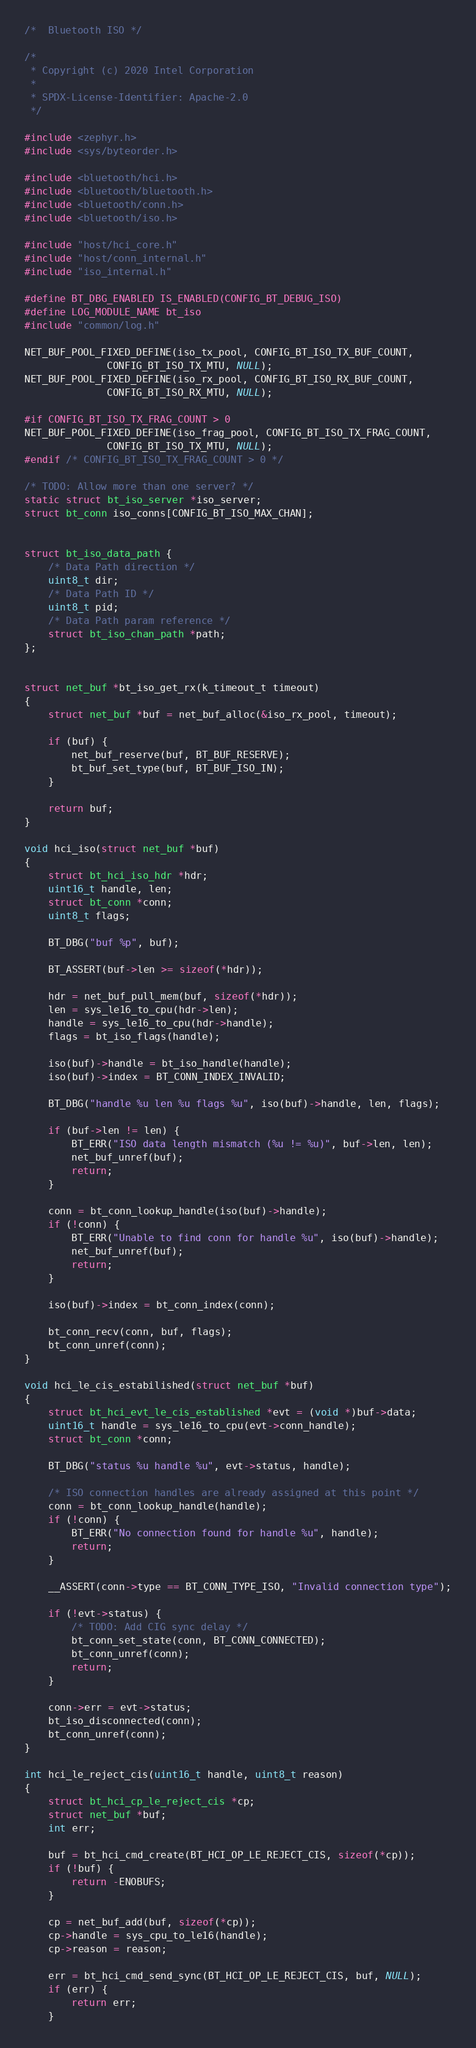<code> <loc_0><loc_0><loc_500><loc_500><_C_>/*  Bluetooth ISO */

/*
 * Copyright (c) 2020 Intel Corporation
 *
 * SPDX-License-Identifier: Apache-2.0
 */

#include <zephyr.h>
#include <sys/byteorder.h>

#include <bluetooth/hci.h>
#include <bluetooth/bluetooth.h>
#include <bluetooth/conn.h>
#include <bluetooth/iso.h>

#include "host/hci_core.h"
#include "host/conn_internal.h"
#include "iso_internal.h"

#define BT_DBG_ENABLED IS_ENABLED(CONFIG_BT_DEBUG_ISO)
#define LOG_MODULE_NAME bt_iso
#include "common/log.h"

NET_BUF_POOL_FIXED_DEFINE(iso_tx_pool, CONFIG_BT_ISO_TX_BUF_COUNT,
			  CONFIG_BT_ISO_TX_MTU, NULL);
NET_BUF_POOL_FIXED_DEFINE(iso_rx_pool, CONFIG_BT_ISO_RX_BUF_COUNT,
			  CONFIG_BT_ISO_RX_MTU, NULL);

#if CONFIG_BT_ISO_TX_FRAG_COUNT > 0
NET_BUF_POOL_FIXED_DEFINE(iso_frag_pool, CONFIG_BT_ISO_TX_FRAG_COUNT,
			  CONFIG_BT_ISO_TX_MTU, NULL);
#endif /* CONFIG_BT_ISO_TX_FRAG_COUNT > 0 */

/* TODO: Allow more than one server? */
static struct bt_iso_server *iso_server;
struct bt_conn iso_conns[CONFIG_BT_ISO_MAX_CHAN];


struct bt_iso_data_path {
	/* Data Path direction */
	uint8_t dir;
	/* Data Path ID */
	uint8_t pid;
	/* Data Path param reference */
	struct bt_iso_chan_path *path;
};


struct net_buf *bt_iso_get_rx(k_timeout_t timeout)
{
	struct net_buf *buf = net_buf_alloc(&iso_rx_pool, timeout);

	if (buf) {
		net_buf_reserve(buf, BT_BUF_RESERVE);
		bt_buf_set_type(buf, BT_BUF_ISO_IN);
	}

	return buf;
}

void hci_iso(struct net_buf *buf)
{
	struct bt_hci_iso_hdr *hdr;
	uint16_t handle, len;
	struct bt_conn *conn;
	uint8_t flags;

	BT_DBG("buf %p", buf);

	BT_ASSERT(buf->len >= sizeof(*hdr));

	hdr = net_buf_pull_mem(buf, sizeof(*hdr));
	len = sys_le16_to_cpu(hdr->len);
	handle = sys_le16_to_cpu(hdr->handle);
	flags = bt_iso_flags(handle);

	iso(buf)->handle = bt_iso_handle(handle);
	iso(buf)->index = BT_CONN_INDEX_INVALID;

	BT_DBG("handle %u len %u flags %u", iso(buf)->handle, len, flags);

	if (buf->len != len) {
		BT_ERR("ISO data length mismatch (%u != %u)", buf->len, len);
		net_buf_unref(buf);
		return;
	}

	conn = bt_conn_lookup_handle(iso(buf)->handle);
	if (!conn) {
		BT_ERR("Unable to find conn for handle %u", iso(buf)->handle);
		net_buf_unref(buf);
		return;
	}

	iso(buf)->index = bt_conn_index(conn);

	bt_conn_recv(conn, buf, flags);
	bt_conn_unref(conn);
}

void hci_le_cis_estabilished(struct net_buf *buf)
{
	struct bt_hci_evt_le_cis_established *evt = (void *)buf->data;
	uint16_t handle = sys_le16_to_cpu(evt->conn_handle);
	struct bt_conn *conn;

	BT_DBG("status %u handle %u", evt->status, handle);

	/* ISO connection handles are already assigned at this point */
	conn = bt_conn_lookup_handle(handle);
	if (!conn) {
		BT_ERR("No connection found for handle %u", handle);
		return;
	}

	__ASSERT(conn->type == BT_CONN_TYPE_ISO, "Invalid connection type");

	if (!evt->status) {
		/* TODO: Add CIG sync delay */
		bt_conn_set_state(conn, BT_CONN_CONNECTED);
		bt_conn_unref(conn);
		return;
	}

	conn->err = evt->status;
	bt_iso_disconnected(conn);
	bt_conn_unref(conn);
}

int hci_le_reject_cis(uint16_t handle, uint8_t reason)
{
	struct bt_hci_cp_le_reject_cis *cp;
	struct net_buf *buf;
	int err;

	buf = bt_hci_cmd_create(BT_HCI_OP_LE_REJECT_CIS, sizeof(*cp));
	if (!buf) {
		return -ENOBUFS;
	}

	cp = net_buf_add(buf, sizeof(*cp));
	cp->handle = sys_cpu_to_le16(handle);
	cp->reason = reason;

	err = bt_hci_cmd_send_sync(BT_HCI_OP_LE_REJECT_CIS, buf, NULL);
	if (err) {
		return err;
	}
</code> 